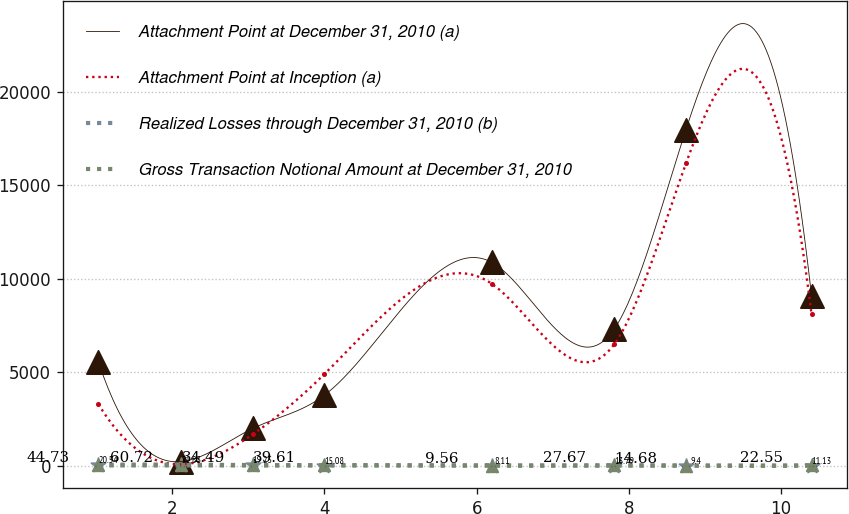<chart> <loc_0><loc_0><loc_500><loc_500><line_chart><ecel><fcel>Attachment Point at December 31, 2010 (a)<fcel>Attachment Point at Inception (a)<fcel>Realized Losses through December 31, 2010 (b)<fcel>Gross Transaction Notional Amount at December 31, 2010<nl><fcel>1.03<fcel>5553.43<fcel>3298.13<fcel>20.54<fcel>44.73<nl><fcel>2.12<fcel>229.06<fcel>80.37<fcel>21.83<fcel>60.72<nl><fcel>3.06<fcel>2003.85<fcel>1689.25<fcel>19.25<fcel>34.49<nl><fcel>4<fcel>3778.64<fcel>4907.01<fcel>15.08<fcel>39.61<nl><fcel>6.2<fcel>10877.8<fcel>9733.65<fcel>8.11<fcel>9.56<nl><fcel>7.81<fcel>7328.22<fcel>6515.89<fcel>13.79<fcel>27.67<nl><fcel>8.75<fcel>17976.9<fcel>16169.2<fcel>9.4<fcel>14.68<nl><fcel>10.4<fcel>9103.01<fcel>8124.77<fcel>11.13<fcel>22.55<nl></chart> 